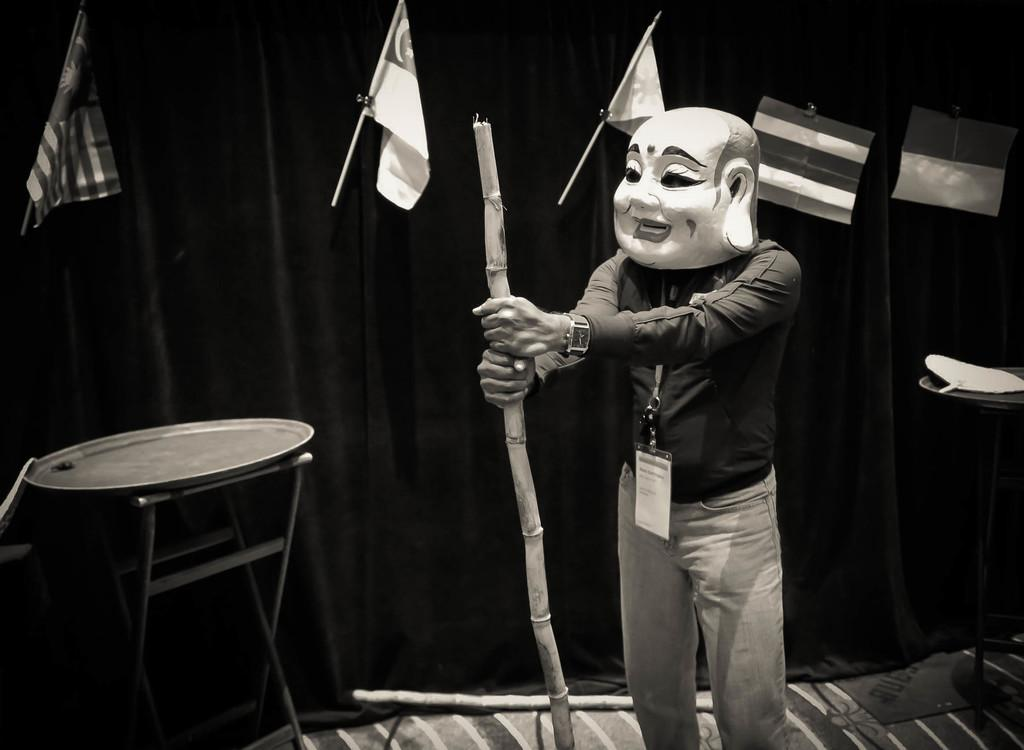What can be seen in the image related to a person? There is a person in the image, and they are wearing a mask and a tag. What is the person holding in the image? The person is holding a stick in the image. What objects are present on a stand and a table in the image? There is a plate on a stand and a paper on a table in the image. What decorative elements are visible on the wall in the image? There are flags hanging on the wall in the image. Can you tell me how many boats are docked in the harbor in the image? There is no harbor or boats present in the image. What type of soda is being served in the image? There is no soda present in the image. 